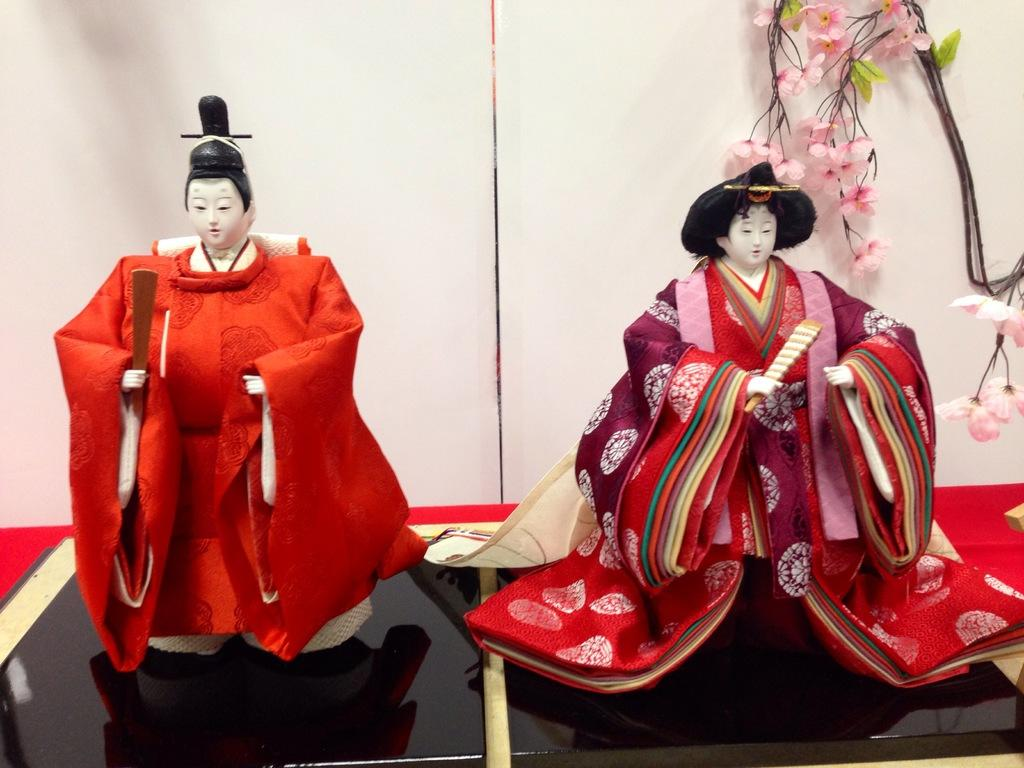What objects can be seen in the foreground of the image? There are toys in the foreground of the image. What is the color of the tiles on which the toys are placed? The toys are on black color tiles. What can be seen in the background of the image? There are flowers, leaves, and a wall in the background of the image. What type of furniture can be seen in the image? There is no furniture present in the image; it features toys on black color tiles with a background of flowers, leaves, and a wall. 